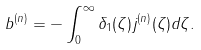<formula> <loc_0><loc_0><loc_500><loc_500>b ^ { ( n ) } = - \int _ { 0 } ^ { \infty } \delta _ { 1 } ( \zeta ) j ^ { ( n ) } ( \zeta ) d \zeta .</formula> 